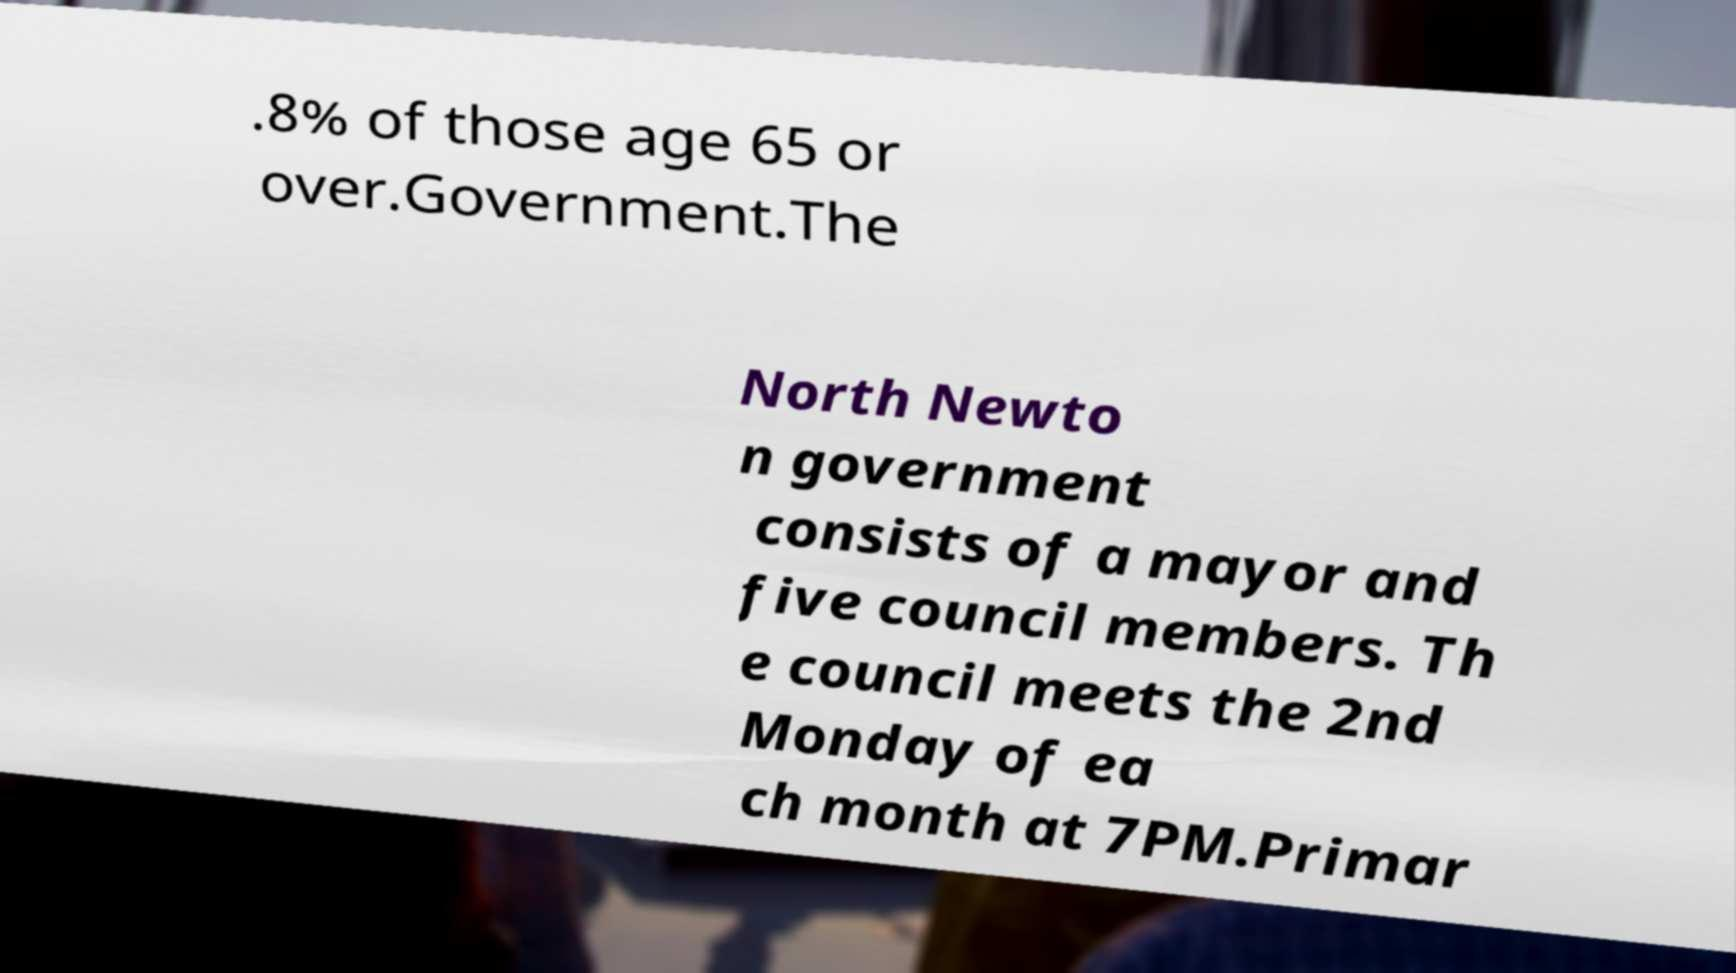Could you extract and type out the text from this image? .8% of those age 65 or over.Government.The North Newto n government consists of a mayor and five council members. Th e council meets the 2nd Monday of ea ch month at 7PM.Primar 